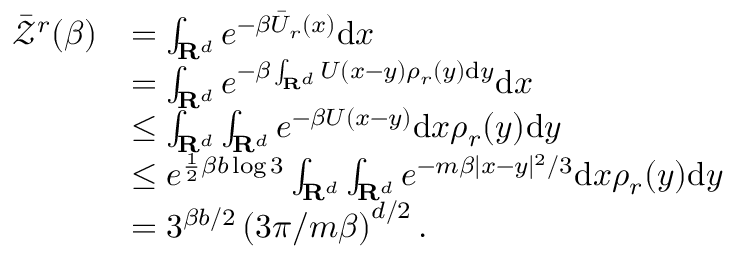<formula> <loc_0><loc_0><loc_500><loc_500>\begin{array} { r l } { \ B a r { \mathcal { Z } } ^ { r } ( \beta ) } & { = \int _ { R ^ { d } } e ^ { - \beta \ B a r { U } _ { r } \left ( x \right ) } d x } \\ & { = \int _ { R ^ { d } } e ^ { - \beta \int _ { R ^ { d } } U ( x - y ) \rho _ { r } ( y ) d y } d x } \\ & { \leq \int _ { R ^ { d } } \int _ { R ^ { d } } e ^ { - \beta U ( x - y ) } d x \rho _ { r } ( y ) d y } \\ & { \leq e ^ { \frac { 1 } { 2 } \beta b \log 3 } \int _ { R ^ { d } } \int _ { R ^ { d } } e ^ { - m \beta | x - y | ^ { 2 } / 3 } d x \rho _ { r } ( y ) d y } \\ & { = 3 ^ { \beta b / 2 } \left ( 3 \pi / m \beta \right ) ^ { d / 2 } . } \end{array}</formula> 